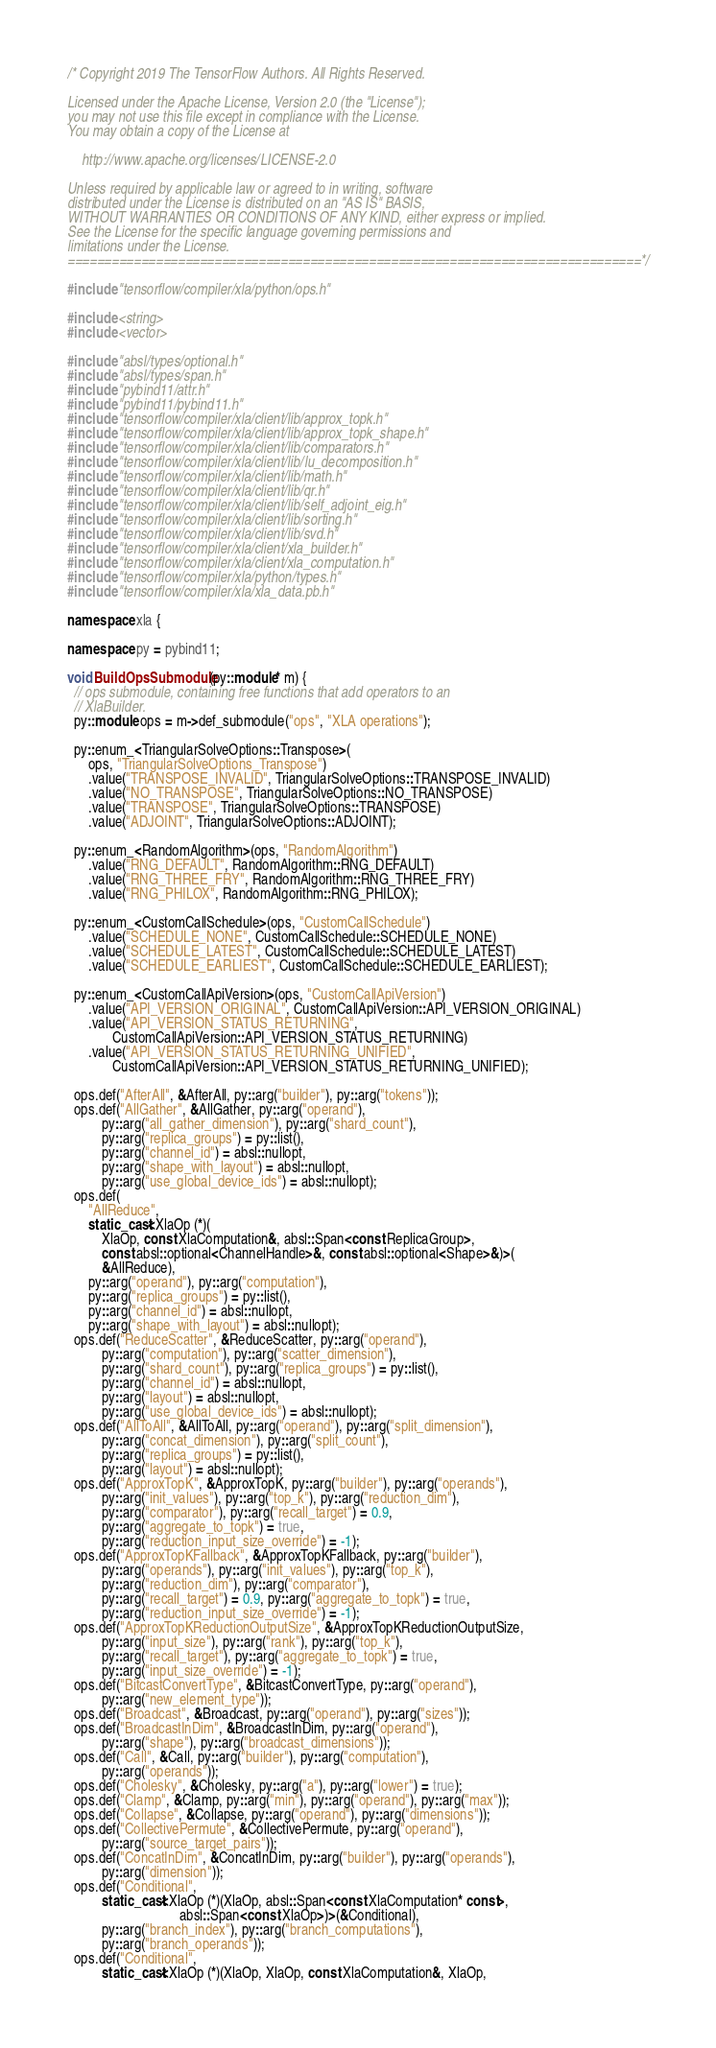Convert code to text. <code><loc_0><loc_0><loc_500><loc_500><_C++_>/* Copyright 2019 The TensorFlow Authors. All Rights Reserved.

Licensed under the Apache License, Version 2.0 (the "License");
you may not use this file except in compliance with the License.
You may obtain a copy of the License at

    http://www.apache.org/licenses/LICENSE-2.0

Unless required by applicable law or agreed to in writing, software
distributed under the License is distributed on an "AS IS" BASIS,
WITHOUT WARRANTIES OR CONDITIONS OF ANY KIND, either express or implied.
See the License for the specific language governing permissions and
limitations under the License.
==============================================================================*/

#include "tensorflow/compiler/xla/python/ops.h"

#include <string>
#include <vector>

#include "absl/types/optional.h"
#include "absl/types/span.h"
#include "pybind11/attr.h"
#include "pybind11/pybind11.h"
#include "tensorflow/compiler/xla/client/lib/approx_topk.h"
#include "tensorflow/compiler/xla/client/lib/approx_topk_shape.h"
#include "tensorflow/compiler/xla/client/lib/comparators.h"
#include "tensorflow/compiler/xla/client/lib/lu_decomposition.h"
#include "tensorflow/compiler/xla/client/lib/math.h"
#include "tensorflow/compiler/xla/client/lib/qr.h"
#include "tensorflow/compiler/xla/client/lib/self_adjoint_eig.h"
#include "tensorflow/compiler/xla/client/lib/sorting.h"
#include "tensorflow/compiler/xla/client/lib/svd.h"
#include "tensorflow/compiler/xla/client/xla_builder.h"
#include "tensorflow/compiler/xla/client/xla_computation.h"
#include "tensorflow/compiler/xla/python/types.h"
#include "tensorflow/compiler/xla/xla_data.pb.h"

namespace xla {

namespace py = pybind11;

void BuildOpsSubmodule(py::module* m) {
  // ops submodule, containing free functions that add operators to an
  // XlaBuilder.
  py::module ops = m->def_submodule("ops", "XLA operations");

  py::enum_<TriangularSolveOptions::Transpose>(
      ops, "TriangularSolveOptions_Transpose")
      .value("TRANSPOSE_INVALID", TriangularSolveOptions::TRANSPOSE_INVALID)
      .value("NO_TRANSPOSE", TriangularSolveOptions::NO_TRANSPOSE)
      .value("TRANSPOSE", TriangularSolveOptions::TRANSPOSE)
      .value("ADJOINT", TriangularSolveOptions::ADJOINT);

  py::enum_<RandomAlgorithm>(ops, "RandomAlgorithm")
      .value("RNG_DEFAULT", RandomAlgorithm::RNG_DEFAULT)
      .value("RNG_THREE_FRY", RandomAlgorithm::RNG_THREE_FRY)
      .value("RNG_PHILOX", RandomAlgorithm::RNG_PHILOX);

  py::enum_<CustomCallSchedule>(ops, "CustomCallSchedule")
      .value("SCHEDULE_NONE", CustomCallSchedule::SCHEDULE_NONE)
      .value("SCHEDULE_LATEST", CustomCallSchedule::SCHEDULE_LATEST)
      .value("SCHEDULE_EARLIEST", CustomCallSchedule::SCHEDULE_EARLIEST);

  py::enum_<CustomCallApiVersion>(ops, "CustomCallApiVersion")
      .value("API_VERSION_ORIGINAL", CustomCallApiVersion::API_VERSION_ORIGINAL)
      .value("API_VERSION_STATUS_RETURNING",
             CustomCallApiVersion::API_VERSION_STATUS_RETURNING)
      .value("API_VERSION_STATUS_RETURNING_UNIFIED",
             CustomCallApiVersion::API_VERSION_STATUS_RETURNING_UNIFIED);

  ops.def("AfterAll", &AfterAll, py::arg("builder"), py::arg("tokens"));
  ops.def("AllGather", &AllGather, py::arg("operand"),
          py::arg("all_gather_dimension"), py::arg("shard_count"),
          py::arg("replica_groups") = py::list(),
          py::arg("channel_id") = absl::nullopt,
          py::arg("shape_with_layout") = absl::nullopt,
          py::arg("use_global_device_ids") = absl::nullopt);
  ops.def(
      "AllReduce",
      static_cast<XlaOp (*)(
          XlaOp, const XlaComputation&, absl::Span<const ReplicaGroup>,
          const absl::optional<ChannelHandle>&, const absl::optional<Shape>&)>(
          &AllReduce),
      py::arg("operand"), py::arg("computation"),
      py::arg("replica_groups") = py::list(),
      py::arg("channel_id") = absl::nullopt,
      py::arg("shape_with_layout") = absl::nullopt);
  ops.def("ReduceScatter", &ReduceScatter, py::arg("operand"),
          py::arg("computation"), py::arg("scatter_dimension"),
          py::arg("shard_count"), py::arg("replica_groups") = py::list(),
          py::arg("channel_id") = absl::nullopt,
          py::arg("layout") = absl::nullopt,
          py::arg("use_global_device_ids") = absl::nullopt);
  ops.def("AllToAll", &AllToAll, py::arg("operand"), py::arg("split_dimension"),
          py::arg("concat_dimension"), py::arg("split_count"),
          py::arg("replica_groups") = py::list(),
          py::arg("layout") = absl::nullopt);
  ops.def("ApproxTopK", &ApproxTopK, py::arg("builder"), py::arg("operands"),
          py::arg("init_values"), py::arg("top_k"), py::arg("reduction_dim"),
          py::arg("comparator"), py::arg("recall_target") = 0.9,
          py::arg("aggregate_to_topk") = true,
          py::arg("reduction_input_size_override") = -1);
  ops.def("ApproxTopKFallback", &ApproxTopKFallback, py::arg("builder"),
          py::arg("operands"), py::arg("init_values"), py::arg("top_k"),
          py::arg("reduction_dim"), py::arg("comparator"),
          py::arg("recall_target") = 0.9, py::arg("aggregate_to_topk") = true,
          py::arg("reduction_input_size_override") = -1);
  ops.def("ApproxTopKReductionOutputSize", &ApproxTopKReductionOutputSize,
          py::arg("input_size"), py::arg("rank"), py::arg("top_k"),
          py::arg("recall_target"), py::arg("aggregate_to_topk") = true,
          py::arg("input_size_override") = -1);
  ops.def("BitcastConvertType", &BitcastConvertType, py::arg("operand"),
          py::arg("new_element_type"));
  ops.def("Broadcast", &Broadcast, py::arg("operand"), py::arg("sizes"));
  ops.def("BroadcastInDim", &BroadcastInDim, py::arg("operand"),
          py::arg("shape"), py::arg("broadcast_dimensions"));
  ops.def("Call", &Call, py::arg("builder"), py::arg("computation"),
          py::arg("operands"));
  ops.def("Cholesky", &Cholesky, py::arg("a"), py::arg("lower") = true);
  ops.def("Clamp", &Clamp, py::arg("min"), py::arg("operand"), py::arg("max"));
  ops.def("Collapse", &Collapse, py::arg("operand"), py::arg("dimensions"));
  ops.def("CollectivePermute", &CollectivePermute, py::arg("operand"),
          py::arg("source_target_pairs"));
  ops.def("ConcatInDim", &ConcatInDim, py::arg("builder"), py::arg("operands"),
          py::arg("dimension"));
  ops.def("Conditional",
          static_cast<XlaOp (*)(XlaOp, absl::Span<const XlaComputation* const>,
                                absl::Span<const XlaOp>)>(&Conditional),
          py::arg("branch_index"), py::arg("branch_computations"),
          py::arg("branch_operands"));
  ops.def("Conditional",
          static_cast<XlaOp (*)(XlaOp, XlaOp, const XlaComputation&, XlaOp,</code> 